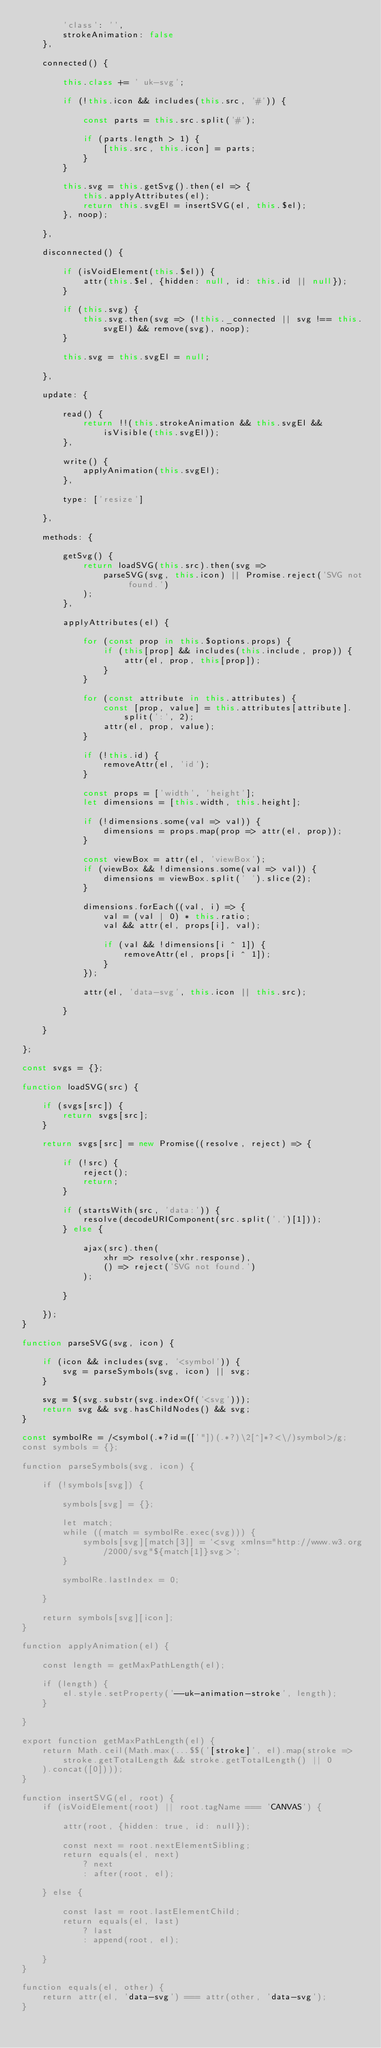Convert code to text. <code><loc_0><loc_0><loc_500><loc_500><_JavaScript_>        'class': '',
        strokeAnimation: false
    },

    connected() {

        this.class += ' uk-svg';

        if (!this.icon && includes(this.src, '#')) {

            const parts = this.src.split('#');

            if (parts.length > 1) {
                [this.src, this.icon] = parts;
            }
        }

        this.svg = this.getSvg().then(el => {
            this.applyAttributes(el);
            return this.svgEl = insertSVG(el, this.$el);
        }, noop);

    },

    disconnected() {

        if (isVoidElement(this.$el)) {
            attr(this.$el, {hidden: null, id: this.id || null});
        }

        if (this.svg) {
            this.svg.then(svg => (!this._connected || svg !== this.svgEl) && remove(svg), noop);
        }

        this.svg = this.svgEl = null;

    },

    update: {

        read() {
            return !!(this.strokeAnimation && this.svgEl && isVisible(this.svgEl));
        },

        write() {
            applyAnimation(this.svgEl);
        },

        type: ['resize']

    },

    methods: {

        getSvg() {
            return loadSVG(this.src).then(svg =>
                parseSVG(svg, this.icon) || Promise.reject('SVG not found.')
            );
        },

        applyAttributes(el) {

            for (const prop in this.$options.props) {
                if (this[prop] && includes(this.include, prop)) {
                    attr(el, prop, this[prop]);
                }
            }

            for (const attribute in this.attributes) {
                const [prop, value] = this.attributes[attribute].split(':', 2);
                attr(el, prop, value);
            }

            if (!this.id) {
                removeAttr(el, 'id');
            }

            const props = ['width', 'height'];
            let dimensions = [this.width, this.height];

            if (!dimensions.some(val => val)) {
                dimensions = props.map(prop => attr(el, prop));
            }

            const viewBox = attr(el, 'viewBox');
            if (viewBox && !dimensions.some(val => val)) {
                dimensions = viewBox.split(' ').slice(2);
            }

            dimensions.forEach((val, i) => {
                val = (val | 0) * this.ratio;
                val && attr(el, props[i], val);

                if (val && !dimensions[i ^ 1]) {
                    removeAttr(el, props[i ^ 1]);
                }
            });

            attr(el, 'data-svg', this.icon || this.src);

        }

    }

};

const svgs = {};

function loadSVG(src) {

    if (svgs[src]) {
        return svgs[src];
    }

    return svgs[src] = new Promise((resolve, reject) => {

        if (!src) {
            reject();
            return;
        }

        if (startsWith(src, 'data:')) {
            resolve(decodeURIComponent(src.split(',')[1]));
        } else {

            ajax(src).then(
                xhr => resolve(xhr.response),
                () => reject('SVG not found.')
            );

        }

    });
}

function parseSVG(svg, icon) {

    if (icon && includes(svg, '<symbol')) {
        svg = parseSymbols(svg, icon) || svg;
    }

    svg = $(svg.substr(svg.indexOf('<svg')));
    return svg && svg.hasChildNodes() && svg;
}

const symbolRe = /<symbol(.*?id=(['"])(.*?)\2[^]*?<\/)symbol>/g;
const symbols = {};

function parseSymbols(svg, icon) {

    if (!symbols[svg]) {

        symbols[svg] = {};

        let match;
        while ((match = symbolRe.exec(svg))) {
            symbols[svg][match[3]] = `<svg xmlns="http://www.w3.org/2000/svg"${match[1]}svg>`;
        }

        symbolRe.lastIndex = 0;

    }

    return symbols[svg][icon];
}

function applyAnimation(el) {

    const length = getMaxPathLength(el);

    if (length) {
        el.style.setProperty('--uk-animation-stroke', length);
    }

}

export function getMaxPathLength(el) {
    return Math.ceil(Math.max(...$$('[stroke]', el).map(stroke =>
        stroke.getTotalLength && stroke.getTotalLength() || 0
    ).concat([0])));
}

function insertSVG(el, root) {
    if (isVoidElement(root) || root.tagName === 'CANVAS') {

        attr(root, {hidden: true, id: null});

        const next = root.nextElementSibling;
        return equals(el, next)
            ? next
            : after(root, el);

    } else {

        const last = root.lastElementChild;
        return equals(el, last)
            ? last
            : append(root, el);

    }
}

function equals(el, other) {
    return attr(el, 'data-svg') === attr(other, 'data-svg');
}
</code> 